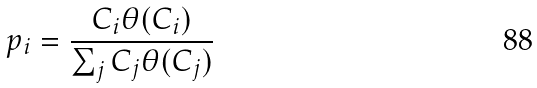<formula> <loc_0><loc_0><loc_500><loc_500>p _ { i } = \frac { C _ { i } \theta ( C _ { i } ) } { \sum _ { j } C _ { j } \theta ( C _ { j } ) }</formula> 